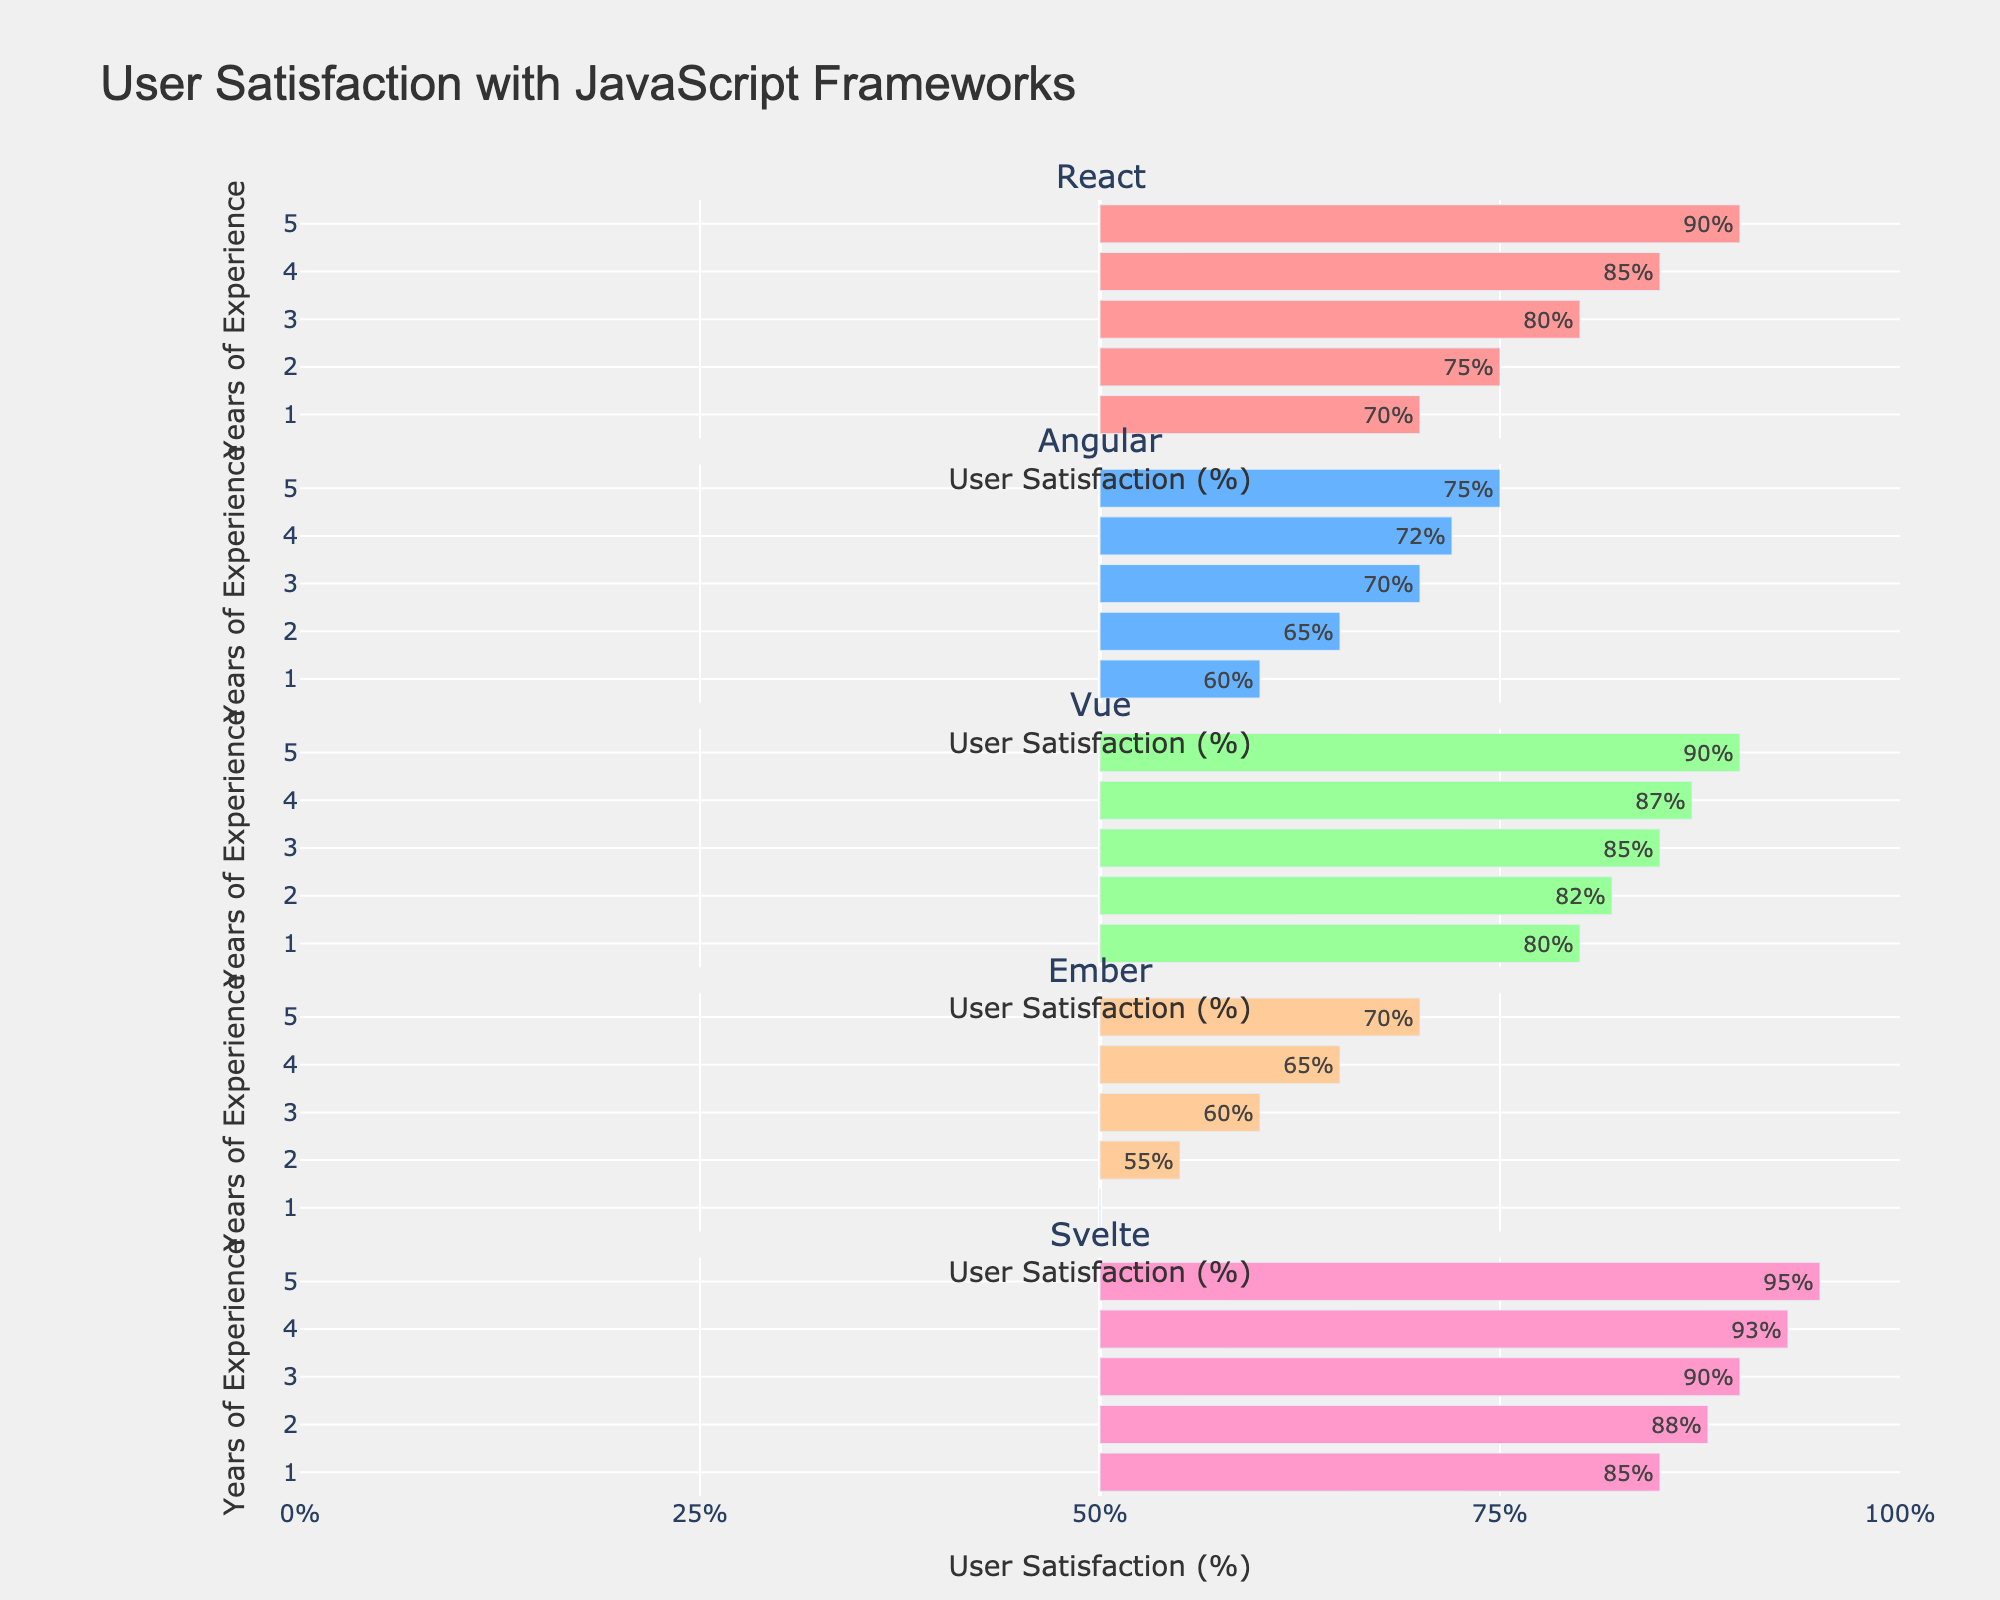Which framework has the highest user satisfaction after 5 years of experience? To determine the framework with the highest user satisfaction at 5 years of experience, look at the user satisfaction values. Svelte shows a satisfaction score of 95%, which is the highest among the frameworks.
Answer: Svelte Which framework has the lowest user satisfaction for developers with 1 year of experience? Check the user satisfaction scores for 1 year of experience. Ember has the lowest user satisfaction at 50%.
Answer: Ember What is the difference in user satisfaction between React and Angular for developers with 3 years of experience? For 3 years of experience, React has a satisfaction score of 80%, and Angular has 70%. The difference is 80% - 70% = 10%.
Answer: 10% If you average the user satisfaction scores for Vue across all years of experience, what do you get? Add Vue's satisfaction scores: 80%, 82%, 85%, 87%, 90%. The total is 424%. Divide by the number of years (5), so 424% / 5 = 84.8%.
Answer: 84.8% Which framework shows the most improvement in user satisfaction from 1 year to 5 years of experience? Calculate the difference in user satisfaction from 1 year to 5 years for each framework. React: 90% - 70% = 20%; Angular: 75% - 60% = 15%; Vue: 90% - 80% = 10%; Ember: 70% - 50% = 20%; Svelte: 95% - 85% = 10%. So, React and Ember both show the most improvement, each 20%.
Answer: React, Ember Which framework has the most consistent user satisfaction across all years of experience (least variation)? Calculate the range (difference between highest and lowest scores) for each framework. React: 90% - 70% = 20%; Angular: 75% - 60% = 15%; Vue: 90% - 80% = 10%; Ember: 70% - 50% = 20%; Svelte: 95% - 85% = 10%. Vue and Svelte both have the smallest range of 10%, indicating the most consistency.
Answer: Vue, Svelte How much higher is Svelte's user satisfaction compared to Ember's for developers with 4 years of experience? Svelte's satisfaction at 4 years is 93%, and Ember's is 65%. The difference is 93% - 65% = 28%.
Answer: 28% Which framework has the steepest increase in user satisfaction between 2 and 3 years of experience? Calculate the difference between 2 and 3 years for each framework. React: 80% - 75% = 5%; Angular: 70% - 65% = 5%; Vue: 85% - 82% = 3%; Ember: 60% - 55% = 5%; Svelte: 90% - 88% = 2%. Multiple frameworks (React, Angular, Ember) show a 5% increase, the steepest in this range.
Answer: React, Angular, Ember 